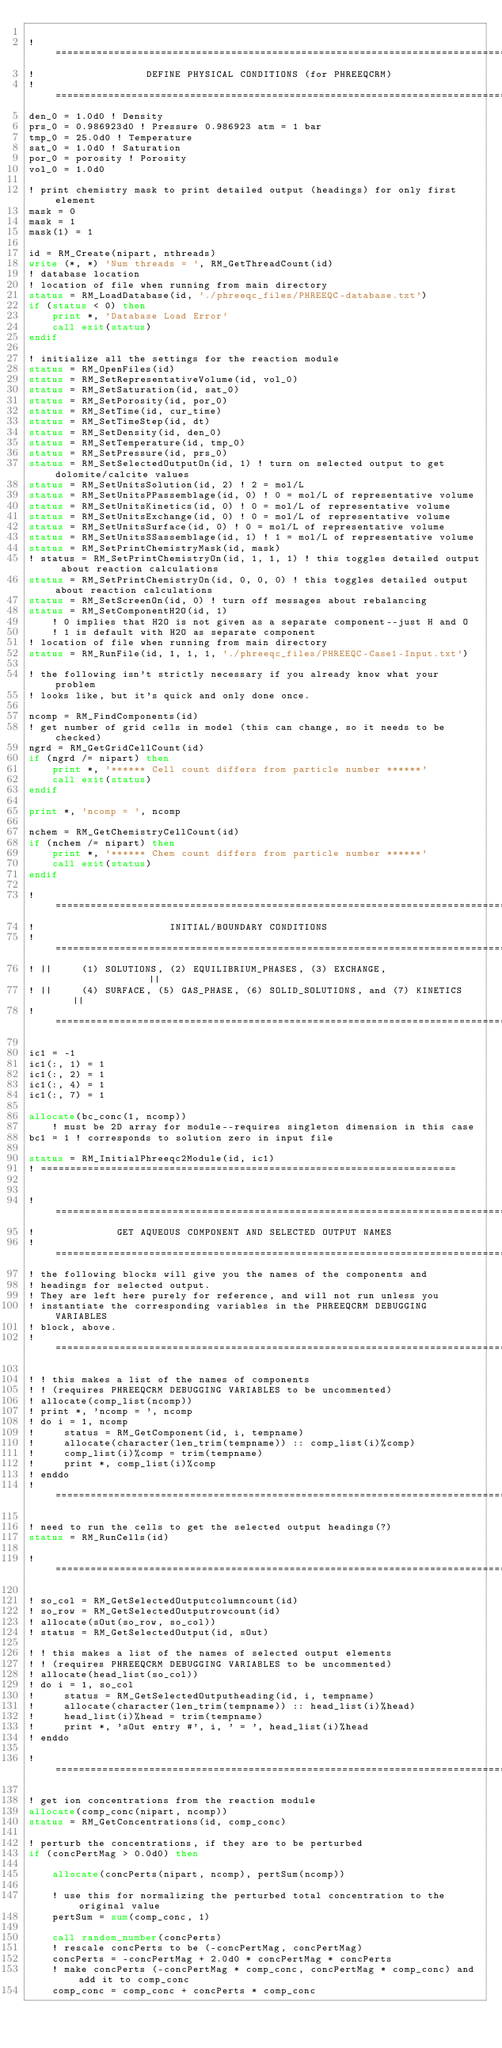<code> <loc_0><loc_0><loc_500><loc_500><_FORTRAN_>
! ==============================================================================
!                   DEFINE PHYSICAL CONDITIONS (for PHREEQCRM)
! ==============================================================================
den_0 = 1.0d0 ! Density
prs_0 = 0.986923d0 ! Pressure 0.986923 atm = 1 bar
tmp_0 = 25.0d0 ! Temperature
sat_0 = 1.0d0 ! Saturation
por_0 = porosity ! Porosity
vol_0 = 1.0d0

! print chemistry mask to print detailed output (headings) for only first element
mask = 0
mask = 1
mask(1) = 1

id = RM_Create(nipart, nthreads)
write (*, *) 'Num threads = ', RM_GetThreadCount(id)
! database location
! location of file when running from main directory
status = RM_LoadDatabase(id, './phreeqc_files/PHREEQC-database.txt')
if (status < 0) then
    print *, 'Database Load Error'
    call exit(status)
endif

! initialize all the settings for the reaction module
status = RM_OpenFiles(id)
status = RM_SetRepresentativeVolume(id, vol_0)
status = RM_SetSaturation(id, sat_0)
status = RM_SetPorosity(id, por_0)
status = RM_SetTime(id, cur_time)
status = RM_SetTimeStep(id, dt)
status = RM_SetDensity(id, den_0)
status = RM_SetTemperature(id, tmp_0)
status = RM_SetPressure(id, prs_0)
status = RM_SetSelectedOutputOn(id, 1) ! turn on selected output to get dolomite/calcite values
status = RM_SetUnitsSolution(id, 2) ! 2 = mol/L
status = RM_SetUnitsPPassemblage(id, 0) ! 0 = mol/L of representative volume
status = RM_SetUnitsKinetics(id, 0) ! 0 = mol/L of representative volume
status = RM_SetUnitsExchange(id, 0) ! 0 = mol/L of representative volume
status = RM_SetUnitsSurface(id, 0) ! 0 = mol/L of representative volume
status = RM_SetUnitsSSassemblage(id, 1) ! 1 = mol/L of representative volume
status = RM_SetPrintChemistryMask(id, mask)
! status = RM_SetPrintChemistryOn(id, 1, 1, 1) ! this toggles detailed output about reaction calculations
status = RM_SetPrintChemistryOn(id, 0, 0, 0) ! this toggles detailed output about reaction calculations
status = RM_SetScreenOn(id, 0) ! turn off messages about rebalancing
status = RM_SetComponentH2O(id, 1)
    ! 0 implies that H2O is not given as a separate component--just H and O
    ! 1 is default with H2O as separate component
! location of file when running from main directory
status = RM_RunFile(id, 1, 1, 1, './phreeqc_files/PHREEQC-Case1-Input.txt')

! the following isn't strictly necessary if you already know what your problem
! looks like, but it's quick and only done once.

ncomp = RM_FindComponents(id)
! get number of grid cells in model (this can change, so it needs to be checked)
ngrd = RM_GetGridCellCount(id)
if (ngrd /= nipart) then
    print *, '****** Cell count differs from particle number ******'
    call exit(status)
endif

print *, 'ncomp = ', ncomp

nchem = RM_GetChemistryCellCount(id)
if (nchem /= nipart) then
    print *, '****** Chem count differs from particle number ******'
    call exit(status)
endif

! ==============================================================================
!                       INITIAL/BOUNDARY CONDITIONS
! ==============================================================================
! ||     (1) SOLUTIONS, (2) EQUILIBRIUM_PHASES, (3) EXCHANGE,                 ||
! ||     (4) SURFACE, (5) GAS_PHASE, (6) SOLID_SOLUTIONS, and (7) KINETICS    ||
! ==============================================================================

ic1 = -1
ic1(:, 1) = 1
ic1(:, 2) = 1
ic1(:, 4) = 1
ic1(:, 7) = 1

allocate(bc_conc(1, ncomp))
    ! must be 2D array for module--requires singleton dimension in this case
bc1 = 1 ! corresponds to solution zero in input file

status = RM_InitialPhreeqc2Module(id, ic1)
! =======================================================================


! ==============================================================================
!              GET AQUEOUS COMPONENT AND SELECTED OUTPUT NAMES
! ==============================================================================
! the following blocks will give you the names of the components and
! headings for selected output.
! They are left here purely for reference, and will not run unless you
! instantiate the corresponding variables in the PHREEQCRM DEBUGGING VARIABLES
! block, above.
! ==============================================================================

! ! this makes a list of the names of components
! ! (requires PHREEQCRM DEBUGGING VARIABLES to be uncommented)
! allocate(comp_list(ncomp))
! print *, 'ncomp = ', ncomp
! do i = 1, ncomp
!     status = RM_GetComponent(id, i, tempname)
!     allocate(character(len_trim(tempname)) :: comp_list(i)%comp)
!     comp_list(i)%comp = trim(tempname)
!     print *, comp_list(i)%comp
! enddo
! ==============================================================================

! need to run the cells to get the selected output headings(?)
status = RM_RunCells(id)

! ==============================================================================

! so_col = RM_GetSelectedOutputcolumncount(id)
! so_row = RM_GetSelectedOutputrowcount(id)
! allocate(sOut(so_row, so_col))
! status = RM_GetSelectedOutput(id, sOut)

! ! this makes a list of the names of selected output elements
! ! (requires PHREEQCRM DEBUGGING VARIABLES to be uncommented)
! allocate(head_list(so_col))
! do i = 1, so_col
!     status = RM_GetSelectedOutputheading(id, i, tempname)
!     allocate(character(len_trim(tempname)) :: head_list(i)%head)
!     head_list(i)%head = trim(tempname)
!     print *, 'sOut entry #', i, ' = ', head_list(i)%head
! enddo

! ==============================================================================

! get ion concentrations from the reaction module
allocate(comp_conc(nipart, ncomp))
status = RM_GetConcentrations(id, comp_conc)

! perturb the concentrations, if they are to be perturbed
if (concPertMag > 0.0d0) then

    allocate(concPerts(nipart, ncomp), pertSum(ncomp))

    ! use this for normalizing the perturbed total concentration to the original value
    pertSum = sum(comp_conc, 1)

    call random_number(concPerts)
    ! rescale concPerts to be (-concPertMag, concPertMag)
    concPerts = -concPertMag + 2.0d0 * concPertMag * concPerts
    ! make concPerts (-concPertMag * comp_conc, concPertMag * comp_conc) and add it to comp_conc
    comp_conc = comp_conc + concPerts * comp_conc
</code> 